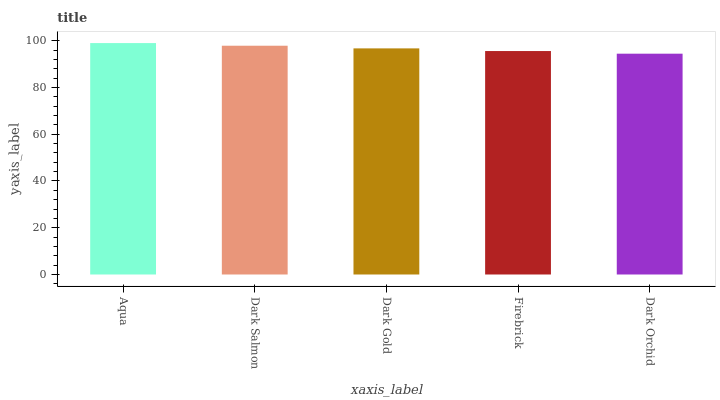Is Dark Salmon the minimum?
Answer yes or no. No. Is Dark Salmon the maximum?
Answer yes or no. No. Is Aqua greater than Dark Salmon?
Answer yes or no. Yes. Is Dark Salmon less than Aqua?
Answer yes or no. Yes. Is Dark Salmon greater than Aqua?
Answer yes or no. No. Is Aqua less than Dark Salmon?
Answer yes or no. No. Is Dark Gold the high median?
Answer yes or no. Yes. Is Dark Gold the low median?
Answer yes or no. Yes. Is Dark Orchid the high median?
Answer yes or no. No. Is Aqua the low median?
Answer yes or no. No. 